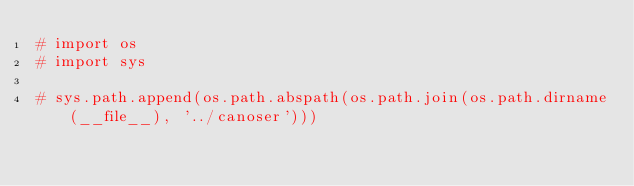<code> <loc_0><loc_0><loc_500><loc_500><_Python_># import os
# import sys

# sys.path.append(os.path.abspath(os.path.join(os.path.dirname(__file__), '../canoser')))</code> 